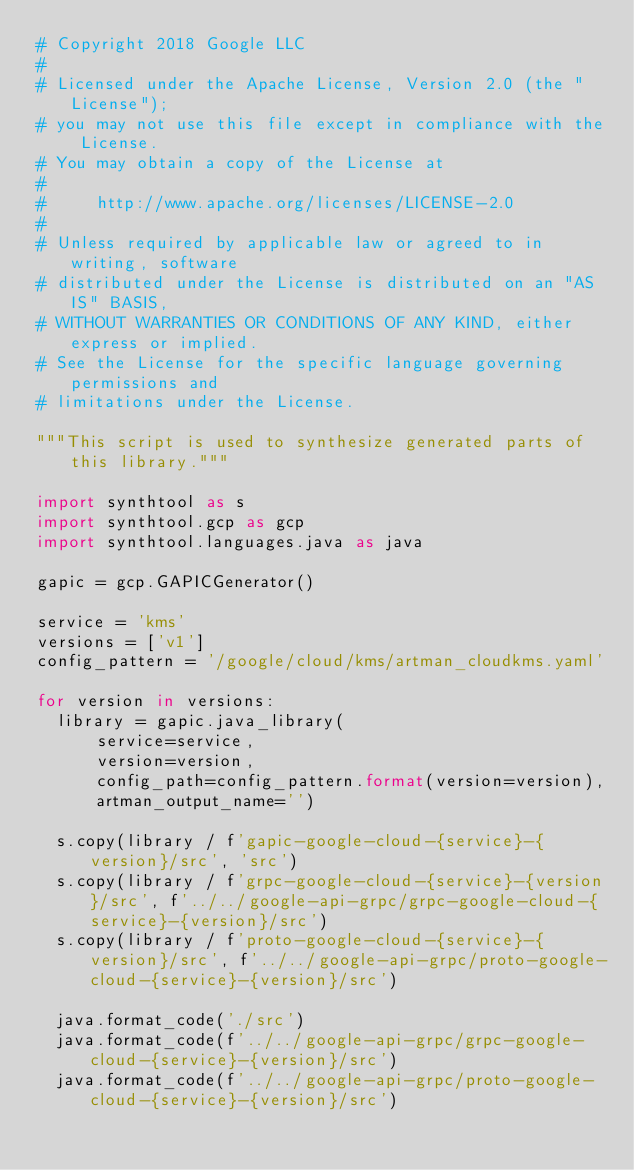<code> <loc_0><loc_0><loc_500><loc_500><_Python_># Copyright 2018 Google LLC
#
# Licensed under the Apache License, Version 2.0 (the "License");
# you may not use this file except in compliance with the License.
# You may obtain a copy of the License at
#
#     http://www.apache.org/licenses/LICENSE-2.0
#
# Unless required by applicable law or agreed to in writing, software
# distributed under the License is distributed on an "AS IS" BASIS,
# WITHOUT WARRANTIES OR CONDITIONS OF ANY KIND, either express or implied.
# See the License for the specific language governing permissions and
# limitations under the License.

"""This script is used to synthesize generated parts of this library."""

import synthtool as s
import synthtool.gcp as gcp
import synthtool.languages.java as java

gapic = gcp.GAPICGenerator()

service = 'kms'
versions = ['v1']
config_pattern = '/google/cloud/kms/artman_cloudkms.yaml'

for version in versions:
  library = gapic.java_library(
      service=service,
      version=version,
      config_path=config_pattern.format(version=version),
      artman_output_name='')

  s.copy(library / f'gapic-google-cloud-{service}-{version}/src', 'src')
  s.copy(library / f'grpc-google-cloud-{service}-{version}/src', f'../../google-api-grpc/grpc-google-cloud-{service}-{version}/src')
  s.copy(library / f'proto-google-cloud-{service}-{version}/src', f'../../google-api-grpc/proto-google-cloud-{service}-{version}/src')

  java.format_code('./src')
  java.format_code(f'../../google-api-grpc/grpc-google-cloud-{service}-{version}/src')
  java.format_code(f'../../google-api-grpc/proto-google-cloud-{service}-{version}/src')
</code> 